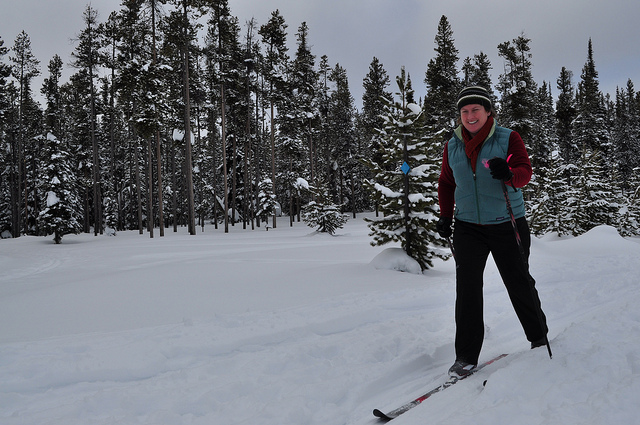<image>What symbol is on the skiers' chest? The symbol on the skiers' chest is not visible in the image. What symbol is on the skiers' chest? I don't know if there is any symbol on the skiers' chest. It is not visible in the image. 